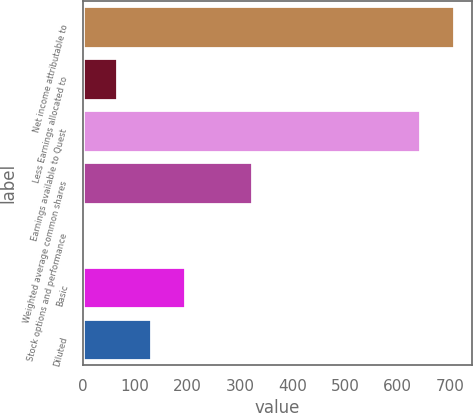Convert chart to OTSL. <chart><loc_0><loc_0><loc_500><loc_500><bar_chart><fcel>Net income attributable to<fcel>Less Earnings allocated to<fcel>Earnings available to Quest<fcel>Weighted average common shares<fcel>Stock options and performance<fcel>Basic<fcel>Diluted<nl><fcel>706.3<fcel>66.3<fcel>642<fcel>323.5<fcel>2<fcel>194.9<fcel>130.6<nl></chart> 